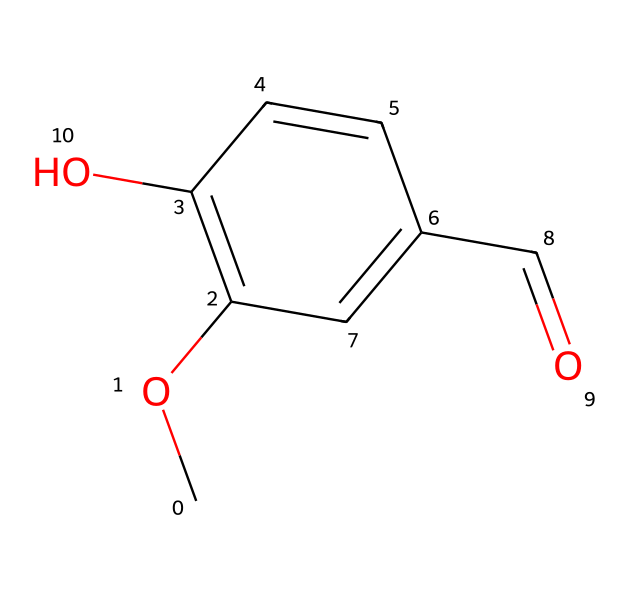What is the molecular formula of vanillin? To determine the molecular formula from the SMILES representation, count the carbon (C), hydrogen (H), and oxygen (O) atoms within the structure. There are 8 carbon atoms, 8 hydrogen atoms, and 3 oxygen atoms present, resulting in the formula C8H8O3.
Answer: C8H8O3 How many rings are present in the molecular structure of vanillin? In the SMILES representation, the structure indicates the presence of one cyclical structure, which is denoted by 'C1', where attachments to other atoms create a ring.
Answer: 1 What type of functional group is present in vanillin? By examining the structure, we can identify the -OH (hydroxyl) group attached to the aromatic ring, characteristic of phenolic compounds. This indicates that vanillin contains a phenolic functional group.
Answer: phenolic Which atom in vanillin indicates the presence of an aldehyde group? The presence of the -CHO group in the structure, identifiable by the carbon atom double bonded to an oxygen atom and single bonded to a hydrogen atom, specifically signals the aldehyde functional group.
Answer: carbon What indicates that vanillin is a phenolic compound? The hydroxyl (-OH) group is directly bonded to an aromatic ring structure, which is a defining feature of phenolic compounds, confirming that vanillin belongs to this category.
Answer: hydroxyl group How many oxygen atoms are present in the structure of vanillin? The SMILES indicates that there are three oxygen atoms visible in different functional groups: one in the hydroxyl group, one in the aldehyde group, and one linked through the ether bond.
Answer: 3 